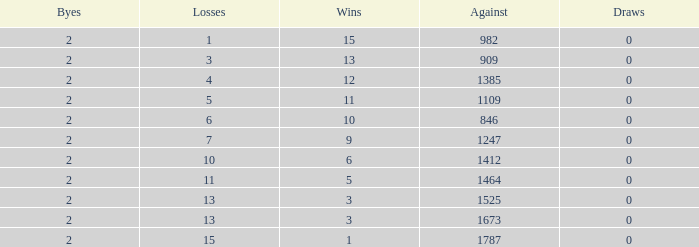What is the average number of Byes when there were less than 0 losses and were against 1247? None. 